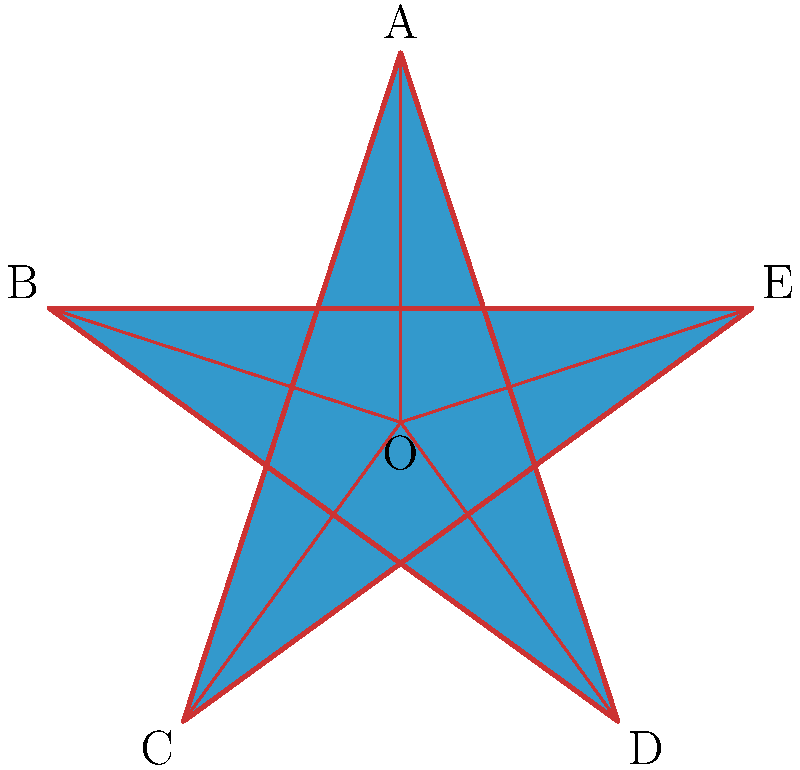In the diagram above, a regular pentagram (five-pointed star) is shown. If the distance from the center O to any of the five points (A, B, C, D, E) is 1 unit, what is the ratio of the length of one of the star's points (e.g., OA) to the length of one of the inner segments (e.g., OB'', where B'' is the point where OB intersects AC)? To solve this problem, we'll use the golden ratio, which is inherent in the geometry of a regular pentagram. Let's follow these steps:

1) In a regular pentagram, the ratio of a diagonal to a side is equal to the golden ratio, $\phi = \frac{1+\sqrt{5}}{2} \approx 1.618$.

2) Let's denote the length of OA as 1 unit, and the length of OB'' as x.

3) In the triangle OAC:
   - OA = 1
   - AC is a diagonal of the pentagon, so AC = $\phi$
   - OC = 1

4) Using the properties of similar triangles:
   $\frac{OA}{OB''} = \frac{AC}{OA}$

5) Substituting the known values:
   $\frac{1}{x} = \frac{\phi}{1}$

6) Solving for x:
   $x = \frac{1}{\phi} = \frac{2}{1+\sqrt{5}} = \phi - 1 \approx 0.618$

7) The ratio we're looking for is OA : OB'' = 1 : x = 1 : ($\phi - 1$) = $\phi : 1$

Therefore, the ratio of OA to OB'' is $\phi : 1$, or approximately 1.618 : 1.
Answer: $\phi : 1$ (or approximately 1.618 : 1) 